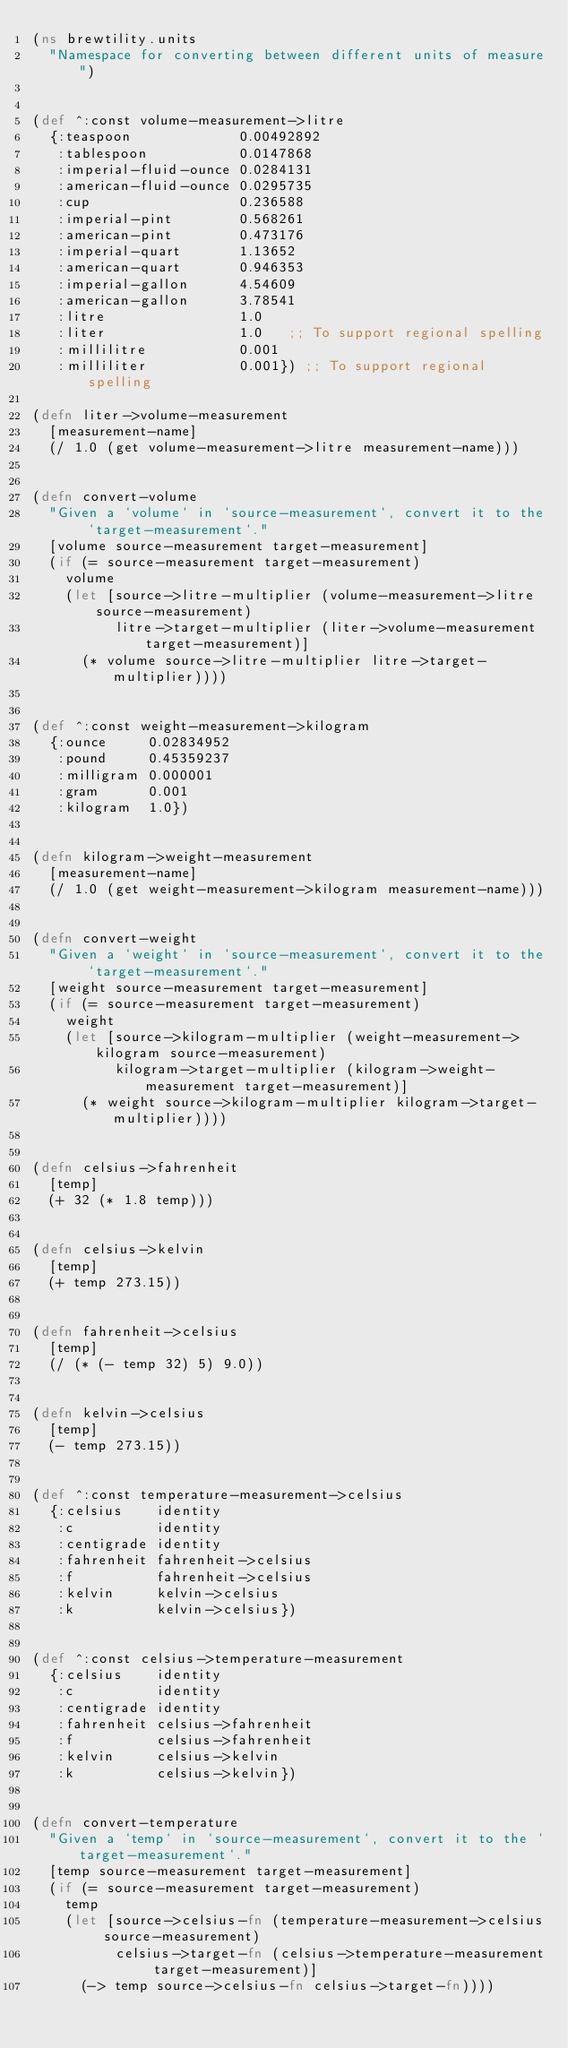Convert code to text. <code><loc_0><loc_0><loc_500><loc_500><_Clojure_>(ns brewtility.units
  "Namespace for converting between different units of measure")


(def ^:const volume-measurement->litre
  {:teaspoon             0.00492892
   :tablespoon           0.0147868
   :imperial-fluid-ounce 0.0284131
   :american-fluid-ounce 0.0295735
   :cup                  0.236588
   :imperial-pint        0.568261
   :american-pint        0.473176
   :imperial-quart       1.13652
   :american-quart       0.946353
   :imperial-gallon      4.54609
   :american-gallon      3.78541
   :litre                1.0
   :liter                1.0   ;; To support regional spelling
   :millilitre           0.001
   :milliliter           0.001}) ;; To support regional spelling

(defn liter->volume-measurement
  [measurement-name]
  (/ 1.0 (get volume-measurement->litre measurement-name)))


(defn convert-volume
  "Given a `volume` in `source-measurement`, convert it to the `target-measurement`."
  [volume source-measurement target-measurement]
  (if (= source-measurement target-measurement)
    volume
    (let [source->litre-multiplier (volume-measurement->litre source-measurement)
          litre->target-multiplier (liter->volume-measurement target-measurement)]
      (* volume source->litre-multiplier litre->target-multiplier))))


(def ^:const weight-measurement->kilogram
  {:ounce     0.02834952
   :pound     0.45359237
   :milligram 0.000001
   :gram      0.001
   :kilogram  1.0})


(defn kilogram->weight-measurement
  [measurement-name]
  (/ 1.0 (get weight-measurement->kilogram measurement-name)))


(defn convert-weight
  "Given a `weight` in `source-measurement`, convert it to the `target-measurement`."
  [weight source-measurement target-measurement]
  (if (= source-measurement target-measurement)
    weight
    (let [source->kilogram-multiplier (weight-measurement->kilogram source-measurement)
          kilogram->target-multiplier (kilogram->weight-measurement target-measurement)]
      (* weight source->kilogram-multiplier kilogram->target-multiplier))))


(defn celsius->fahrenheit
  [temp]
  (+ 32 (* 1.8 temp)))


(defn celsius->kelvin
  [temp]
  (+ temp 273.15))


(defn fahrenheit->celsius
  [temp]
  (/ (* (- temp 32) 5) 9.0))


(defn kelvin->celsius
  [temp]
  (- temp 273.15))


(def ^:const temperature-measurement->celsius
  {:celsius    identity
   :c          identity
   :centigrade identity
   :fahrenheit fahrenheit->celsius
   :f          fahrenheit->celsius
   :kelvin     kelvin->celsius
   :k          kelvin->celsius})


(def ^:const celsius->temperature-measurement
  {:celsius    identity
   :c          identity
   :centigrade identity
   :fahrenheit celsius->fahrenheit
   :f          celsius->fahrenheit
   :kelvin     celsius->kelvin
   :k          celsius->kelvin})


(defn convert-temperature
  "Given a `temp` in `source-measurement`, convert it to the `target-measurement`."
  [temp source-measurement target-measurement]
  (if (= source-measurement target-measurement)
    temp
    (let [source->celsius-fn (temperature-measurement->celsius source-measurement)
          celsius->target-fn (celsius->temperature-measurement target-measurement)]
      (-> temp source->celsius-fn celsius->target-fn))))
</code> 